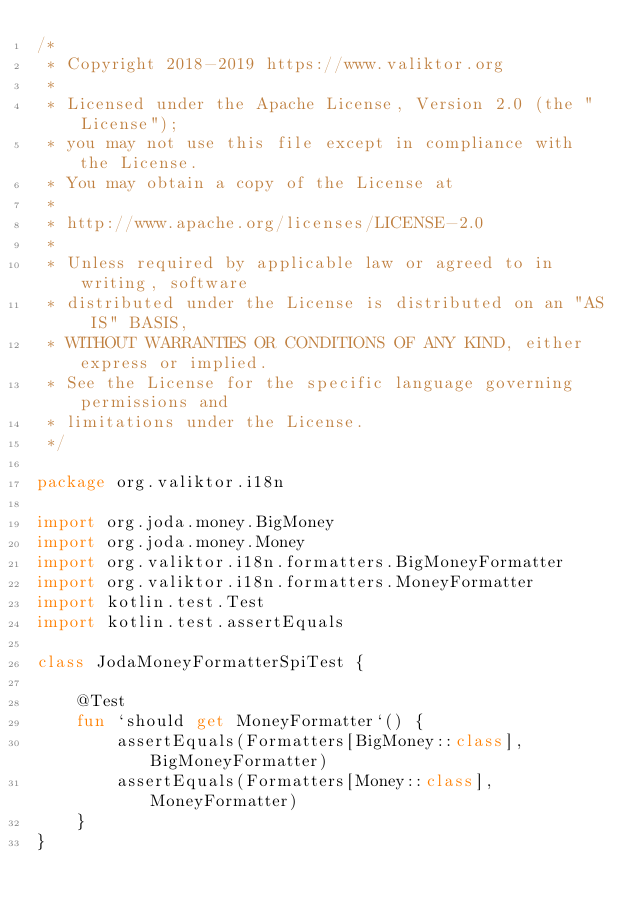<code> <loc_0><loc_0><loc_500><loc_500><_Kotlin_>/*
 * Copyright 2018-2019 https://www.valiktor.org
 *
 * Licensed under the Apache License, Version 2.0 (the "License");
 * you may not use this file except in compliance with the License.
 * You may obtain a copy of the License at
 *
 * http://www.apache.org/licenses/LICENSE-2.0
 *
 * Unless required by applicable law or agreed to in writing, software
 * distributed under the License is distributed on an "AS IS" BASIS,
 * WITHOUT WARRANTIES OR CONDITIONS OF ANY KIND, either express or implied.
 * See the License for the specific language governing permissions and
 * limitations under the License.
 */

package org.valiktor.i18n

import org.joda.money.BigMoney
import org.joda.money.Money
import org.valiktor.i18n.formatters.BigMoneyFormatter
import org.valiktor.i18n.formatters.MoneyFormatter
import kotlin.test.Test
import kotlin.test.assertEquals

class JodaMoneyFormatterSpiTest {

    @Test
    fun `should get MoneyFormatter`() {
        assertEquals(Formatters[BigMoney::class], BigMoneyFormatter)
        assertEquals(Formatters[Money::class], MoneyFormatter)
    }
}</code> 